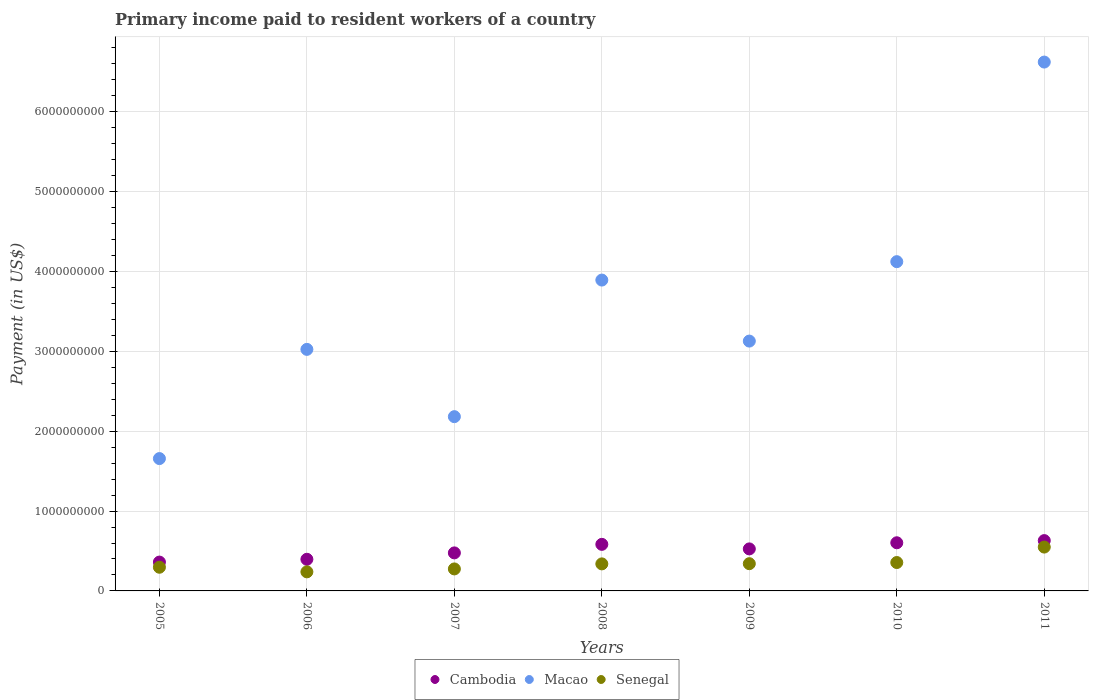How many different coloured dotlines are there?
Provide a short and direct response. 3. Is the number of dotlines equal to the number of legend labels?
Ensure brevity in your answer.  Yes. What is the amount paid to workers in Macao in 2006?
Your response must be concise. 3.02e+09. Across all years, what is the maximum amount paid to workers in Senegal?
Keep it short and to the point. 5.49e+08. Across all years, what is the minimum amount paid to workers in Cambodia?
Your answer should be compact. 3.61e+08. In which year was the amount paid to workers in Macao maximum?
Your answer should be very brief. 2011. What is the total amount paid to workers in Cambodia in the graph?
Provide a short and direct response. 3.58e+09. What is the difference between the amount paid to workers in Macao in 2006 and that in 2007?
Keep it short and to the point. 8.42e+08. What is the difference between the amount paid to workers in Macao in 2006 and the amount paid to workers in Cambodia in 2010?
Keep it short and to the point. 2.42e+09. What is the average amount paid to workers in Cambodia per year?
Offer a very short reply. 5.11e+08. In the year 2008, what is the difference between the amount paid to workers in Macao and amount paid to workers in Cambodia?
Your answer should be very brief. 3.31e+09. What is the ratio of the amount paid to workers in Cambodia in 2006 to that in 2011?
Ensure brevity in your answer.  0.63. Is the difference between the amount paid to workers in Macao in 2006 and 2011 greater than the difference between the amount paid to workers in Cambodia in 2006 and 2011?
Ensure brevity in your answer.  No. What is the difference between the highest and the second highest amount paid to workers in Cambodia?
Provide a succinct answer. 2.71e+07. What is the difference between the highest and the lowest amount paid to workers in Macao?
Offer a terse response. 4.96e+09. In how many years, is the amount paid to workers in Cambodia greater than the average amount paid to workers in Cambodia taken over all years?
Provide a succinct answer. 4. Is the sum of the amount paid to workers in Macao in 2007 and 2009 greater than the maximum amount paid to workers in Cambodia across all years?
Your response must be concise. Yes. Is it the case that in every year, the sum of the amount paid to workers in Cambodia and amount paid to workers in Senegal  is greater than the amount paid to workers in Macao?
Offer a terse response. No. Does the graph contain grids?
Give a very brief answer. Yes. How many legend labels are there?
Your response must be concise. 3. What is the title of the graph?
Provide a short and direct response. Primary income paid to resident workers of a country. What is the label or title of the Y-axis?
Provide a succinct answer. Payment (in US$). What is the Payment (in US$) of Cambodia in 2005?
Give a very brief answer. 3.61e+08. What is the Payment (in US$) of Macao in 2005?
Your answer should be very brief. 1.66e+09. What is the Payment (in US$) in Senegal in 2005?
Make the answer very short. 2.96e+08. What is the Payment (in US$) of Cambodia in 2006?
Ensure brevity in your answer.  3.96e+08. What is the Payment (in US$) in Macao in 2006?
Offer a terse response. 3.02e+09. What is the Payment (in US$) of Senegal in 2006?
Give a very brief answer. 2.39e+08. What is the Payment (in US$) of Cambodia in 2007?
Your answer should be very brief. 4.76e+08. What is the Payment (in US$) in Macao in 2007?
Your response must be concise. 2.18e+09. What is the Payment (in US$) of Senegal in 2007?
Your response must be concise. 2.75e+08. What is the Payment (in US$) in Cambodia in 2008?
Provide a short and direct response. 5.83e+08. What is the Payment (in US$) of Macao in 2008?
Provide a short and direct response. 3.89e+09. What is the Payment (in US$) of Senegal in 2008?
Give a very brief answer. 3.39e+08. What is the Payment (in US$) in Cambodia in 2009?
Offer a very short reply. 5.26e+08. What is the Payment (in US$) in Macao in 2009?
Ensure brevity in your answer.  3.13e+09. What is the Payment (in US$) in Senegal in 2009?
Provide a succinct answer. 3.41e+08. What is the Payment (in US$) of Cambodia in 2010?
Make the answer very short. 6.03e+08. What is the Payment (in US$) in Macao in 2010?
Provide a succinct answer. 4.12e+09. What is the Payment (in US$) of Senegal in 2010?
Provide a short and direct response. 3.56e+08. What is the Payment (in US$) of Cambodia in 2011?
Make the answer very short. 6.30e+08. What is the Payment (in US$) of Macao in 2011?
Provide a succinct answer. 6.62e+09. What is the Payment (in US$) in Senegal in 2011?
Your answer should be compact. 5.49e+08. Across all years, what is the maximum Payment (in US$) of Cambodia?
Give a very brief answer. 6.30e+08. Across all years, what is the maximum Payment (in US$) in Macao?
Keep it short and to the point. 6.62e+09. Across all years, what is the maximum Payment (in US$) in Senegal?
Your response must be concise. 5.49e+08. Across all years, what is the minimum Payment (in US$) in Cambodia?
Keep it short and to the point. 3.61e+08. Across all years, what is the minimum Payment (in US$) in Macao?
Keep it short and to the point. 1.66e+09. Across all years, what is the minimum Payment (in US$) of Senegal?
Ensure brevity in your answer.  2.39e+08. What is the total Payment (in US$) in Cambodia in the graph?
Offer a very short reply. 3.58e+09. What is the total Payment (in US$) in Macao in the graph?
Provide a short and direct response. 2.46e+1. What is the total Payment (in US$) of Senegal in the graph?
Provide a succinct answer. 2.39e+09. What is the difference between the Payment (in US$) in Cambodia in 2005 and that in 2006?
Ensure brevity in your answer.  -3.50e+07. What is the difference between the Payment (in US$) in Macao in 2005 and that in 2006?
Make the answer very short. -1.37e+09. What is the difference between the Payment (in US$) in Senegal in 2005 and that in 2006?
Make the answer very short. 5.77e+07. What is the difference between the Payment (in US$) of Cambodia in 2005 and that in 2007?
Offer a very short reply. -1.15e+08. What is the difference between the Payment (in US$) in Macao in 2005 and that in 2007?
Offer a terse response. -5.25e+08. What is the difference between the Payment (in US$) in Senegal in 2005 and that in 2007?
Keep it short and to the point. 2.11e+07. What is the difference between the Payment (in US$) in Cambodia in 2005 and that in 2008?
Offer a very short reply. -2.22e+08. What is the difference between the Payment (in US$) of Macao in 2005 and that in 2008?
Provide a short and direct response. -2.24e+09. What is the difference between the Payment (in US$) of Senegal in 2005 and that in 2008?
Your answer should be compact. -4.20e+07. What is the difference between the Payment (in US$) in Cambodia in 2005 and that in 2009?
Your answer should be very brief. -1.65e+08. What is the difference between the Payment (in US$) in Macao in 2005 and that in 2009?
Keep it short and to the point. -1.47e+09. What is the difference between the Payment (in US$) of Senegal in 2005 and that in 2009?
Offer a very short reply. -4.46e+07. What is the difference between the Payment (in US$) of Cambodia in 2005 and that in 2010?
Your answer should be compact. -2.42e+08. What is the difference between the Payment (in US$) of Macao in 2005 and that in 2010?
Ensure brevity in your answer.  -2.47e+09. What is the difference between the Payment (in US$) of Senegal in 2005 and that in 2010?
Provide a short and direct response. -5.90e+07. What is the difference between the Payment (in US$) of Cambodia in 2005 and that in 2011?
Offer a terse response. -2.69e+08. What is the difference between the Payment (in US$) of Macao in 2005 and that in 2011?
Offer a terse response. -4.96e+09. What is the difference between the Payment (in US$) of Senegal in 2005 and that in 2011?
Make the answer very short. -2.52e+08. What is the difference between the Payment (in US$) in Cambodia in 2006 and that in 2007?
Ensure brevity in your answer.  -8.00e+07. What is the difference between the Payment (in US$) of Macao in 2006 and that in 2007?
Offer a terse response. 8.42e+08. What is the difference between the Payment (in US$) in Senegal in 2006 and that in 2007?
Your response must be concise. -3.67e+07. What is the difference between the Payment (in US$) in Cambodia in 2006 and that in 2008?
Your answer should be very brief. -1.87e+08. What is the difference between the Payment (in US$) of Macao in 2006 and that in 2008?
Your answer should be very brief. -8.68e+08. What is the difference between the Payment (in US$) in Senegal in 2006 and that in 2008?
Your response must be concise. -9.97e+07. What is the difference between the Payment (in US$) of Cambodia in 2006 and that in 2009?
Your answer should be very brief. -1.30e+08. What is the difference between the Payment (in US$) in Macao in 2006 and that in 2009?
Keep it short and to the point. -1.04e+08. What is the difference between the Payment (in US$) in Senegal in 2006 and that in 2009?
Provide a succinct answer. -1.02e+08. What is the difference between the Payment (in US$) of Cambodia in 2006 and that in 2010?
Your answer should be compact. -2.07e+08. What is the difference between the Payment (in US$) in Macao in 2006 and that in 2010?
Make the answer very short. -1.10e+09. What is the difference between the Payment (in US$) in Senegal in 2006 and that in 2010?
Your answer should be compact. -1.17e+08. What is the difference between the Payment (in US$) in Cambodia in 2006 and that in 2011?
Provide a short and direct response. -2.34e+08. What is the difference between the Payment (in US$) of Macao in 2006 and that in 2011?
Your answer should be compact. -3.60e+09. What is the difference between the Payment (in US$) in Senegal in 2006 and that in 2011?
Ensure brevity in your answer.  -3.10e+08. What is the difference between the Payment (in US$) in Cambodia in 2007 and that in 2008?
Your response must be concise. -1.07e+08. What is the difference between the Payment (in US$) of Macao in 2007 and that in 2008?
Provide a succinct answer. -1.71e+09. What is the difference between the Payment (in US$) in Senegal in 2007 and that in 2008?
Give a very brief answer. -6.31e+07. What is the difference between the Payment (in US$) of Cambodia in 2007 and that in 2009?
Provide a short and direct response. -4.99e+07. What is the difference between the Payment (in US$) in Macao in 2007 and that in 2009?
Provide a short and direct response. -9.46e+08. What is the difference between the Payment (in US$) of Senegal in 2007 and that in 2009?
Offer a very short reply. -6.56e+07. What is the difference between the Payment (in US$) of Cambodia in 2007 and that in 2010?
Give a very brief answer. -1.27e+08. What is the difference between the Payment (in US$) of Macao in 2007 and that in 2010?
Offer a very short reply. -1.94e+09. What is the difference between the Payment (in US$) in Senegal in 2007 and that in 2010?
Offer a very short reply. -8.01e+07. What is the difference between the Payment (in US$) in Cambodia in 2007 and that in 2011?
Make the answer very short. -1.54e+08. What is the difference between the Payment (in US$) in Macao in 2007 and that in 2011?
Your answer should be compact. -4.44e+09. What is the difference between the Payment (in US$) of Senegal in 2007 and that in 2011?
Give a very brief answer. -2.74e+08. What is the difference between the Payment (in US$) of Cambodia in 2008 and that in 2009?
Make the answer very short. 5.69e+07. What is the difference between the Payment (in US$) in Macao in 2008 and that in 2009?
Make the answer very short. 7.64e+08. What is the difference between the Payment (in US$) of Senegal in 2008 and that in 2009?
Your answer should be very brief. -2.51e+06. What is the difference between the Payment (in US$) in Cambodia in 2008 and that in 2010?
Your response must be concise. -1.99e+07. What is the difference between the Payment (in US$) in Macao in 2008 and that in 2010?
Your answer should be very brief. -2.30e+08. What is the difference between the Payment (in US$) of Senegal in 2008 and that in 2010?
Your answer should be very brief. -1.70e+07. What is the difference between the Payment (in US$) in Cambodia in 2008 and that in 2011?
Ensure brevity in your answer.  -4.70e+07. What is the difference between the Payment (in US$) of Macao in 2008 and that in 2011?
Provide a short and direct response. -2.73e+09. What is the difference between the Payment (in US$) of Senegal in 2008 and that in 2011?
Your response must be concise. -2.10e+08. What is the difference between the Payment (in US$) in Cambodia in 2009 and that in 2010?
Ensure brevity in your answer.  -7.68e+07. What is the difference between the Payment (in US$) in Macao in 2009 and that in 2010?
Your answer should be compact. -9.95e+08. What is the difference between the Payment (in US$) in Senegal in 2009 and that in 2010?
Make the answer very short. -1.45e+07. What is the difference between the Payment (in US$) of Cambodia in 2009 and that in 2011?
Your response must be concise. -1.04e+08. What is the difference between the Payment (in US$) of Macao in 2009 and that in 2011?
Give a very brief answer. -3.49e+09. What is the difference between the Payment (in US$) of Senegal in 2009 and that in 2011?
Keep it short and to the point. -2.08e+08. What is the difference between the Payment (in US$) in Cambodia in 2010 and that in 2011?
Your answer should be compact. -2.71e+07. What is the difference between the Payment (in US$) in Macao in 2010 and that in 2011?
Provide a short and direct response. -2.50e+09. What is the difference between the Payment (in US$) of Senegal in 2010 and that in 2011?
Ensure brevity in your answer.  -1.93e+08. What is the difference between the Payment (in US$) in Cambodia in 2005 and the Payment (in US$) in Macao in 2006?
Keep it short and to the point. -2.66e+09. What is the difference between the Payment (in US$) in Cambodia in 2005 and the Payment (in US$) in Senegal in 2006?
Ensure brevity in your answer.  1.22e+08. What is the difference between the Payment (in US$) in Macao in 2005 and the Payment (in US$) in Senegal in 2006?
Your answer should be very brief. 1.42e+09. What is the difference between the Payment (in US$) of Cambodia in 2005 and the Payment (in US$) of Macao in 2007?
Give a very brief answer. -1.82e+09. What is the difference between the Payment (in US$) in Cambodia in 2005 and the Payment (in US$) in Senegal in 2007?
Keep it short and to the point. 8.57e+07. What is the difference between the Payment (in US$) of Macao in 2005 and the Payment (in US$) of Senegal in 2007?
Your answer should be very brief. 1.38e+09. What is the difference between the Payment (in US$) in Cambodia in 2005 and the Payment (in US$) in Macao in 2008?
Make the answer very short. -3.53e+09. What is the difference between the Payment (in US$) in Cambodia in 2005 and the Payment (in US$) in Senegal in 2008?
Offer a terse response. 2.26e+07. What is the difference between the Payment (in US$) of Macao in 2005 and the Payment (in US$) of Senegal in 2008?
Offer a very short reply. 1.32e+09. What is the difference between the Payment (in US$) of Cambodia in 2005 and the Payment (in US$) of Macao in 2009?
Your answer should be very brief. -2.77e+09. What is the difference between the Payment (in US$) of Cambodia in 2005 and the Payment (in US$) of Senegal in 2009?
Provide a succinct answer. 2.01e+07. What is the difference between the Payment (in US$) of Macao in 2005 and the Payment (in US$) of Senegal in 2009?
Ensure brevity in your answer.  1.32e+09. What is the difference between the Payment (in US$) of Cambodia in 2005 and the Payment (in US$) of Macao in 2010?
Offer a terse response. -3.76e+09. What is the difference between the Payment (in US$) in Cambodia in 2005 and the Payment (in US$) in Senegal in 2010?
Make the answer very short. 5.60e+06. What is the difference between the Payment (in US$) in Macao in 2005 and the Payment (in US$) in Senegal in 2010?
Your answer should be compact. 1.30e+09. What is the difference between the Payment (in US$) in Cambodia in 2005 and the Payment (in US$) in Macao in 2011?
Provide a succinct answer. -6.26e+09. What is the difference between the Payment (in US$) of Cambodia in 2005 and the Payment (in US$) of Senegal in 2011?
Provide a short and direct response. -1.88e+08. What is the difference between the Payment (in US$) in Macao in 2005 and the Payment (in US$) in Senegal in 2011?
Offer a terse response. 1.11e+09. What is the difference between the Payment (in US$) of Cambodia in 2006 and the Payment (in US$) of Macao in 2007?
Ensure brevity in your answer.  -1.79e+09. What is the difference between the Payment (in US$) of Cambodia in 2006 and the Payment (in US$) of Senegal in 2007?
Make the answer very short. 1.21e+08. What is the difference between the Payment (in US$) in Macao in 2006 and the Payment (in US$) in Senegal in 2007?
Make the answer very short. 2.75e+09. What is the difference between the Payment (in US$) in Cambodia in 2006 and the Payment (in US$) in Macao in 2008?
Ensure brevity in your answer.  -3.50e+09. What is the difference between the Payment (in US$) of Cambodia in 2006 and the Payment (in US$) of Senegal in 2008?
Give a very brief answer. 5.76e+07. What is the difference between the Payment (in US$) in Macao in 2006 and the Payment (in US$) in Senegal in 2008?
Ensure brevity in your answer.  2.69e+09. What is the difference between the Payment (in US$) in Cambodia in 2006 and the Payment (in US$) in Macao in 2009?
Keep it short and to the point. -2.73e+09. What is the difference between the Payment (in US$) in Cambodia in 2006 and the Payment (in US$) in Senegal in 2009?
Your response must be concise. 5.51e+07. What is the difference between the Payment (in US$) of Macao in 2006 and the Payment (in US$) of Senegal in 2009?
Provide a succinct answer. 2.68e+09. What is the difference between the Payment (in US$) in Cambodia in 2006 and the Payment (in US$) in Macao in 2010?
Provide a succinct answer. -3.73e+09. What is the difference between the Payment (in US$) of Cambodia in 2006 and the Payment (in US$) of Senegal in 2010?
Provide a succinct answer. 4.06e+07. What is the difference between the Payment (in US$) in Macao in 2006 and the Payment (in US$) in Senegal in 2010?
Ensure brevity in your answer.  2.67e+09. What is the difference between the Payment (in US$) of Cambodia in 2006 and the Payment (in US$) of Macao in 2011?
Provide a short and direct response. -6.23e+09. What is the difference between the Payment (in US$) in Cambodia in 2006 and the Payment (in US$) in Senegal in 2011?
Your answer should be compact. -1.53e+08. What is the difference between the Payment (in US$) of Macao in 2006 and the Payment (in US$) of Senegal in 2011?
Offer a very short reply. 2.48e+09. What is the difference between the Payment (in US$) in Cambodia in 2007 and the Payment (in US$) in Macao in 2008?
Make the answer very short. -3.42e+09. What is the difference between the Payment (in US$) in Cambodia in 2007 and the Payment (in US$) in Senegal in 2008?
Your answer should be very brief. 1.38e+08. What is the difference between the Payment (in US$) of Macao in 2007 and the Payment (in US$) of Senegal in 2008?
Give a very brief answer. 1.84e+09. What is the difference between the Payment (in US$) of Cambodia in 2007 and the Payment (in US$) of Macao in 2009?
Your answer should be compact. -2.65e+09. What is the difference between the Payment (in US$) of Cambodia in 2007 and the Payment (in US$) of Senegal in 2009?
Your answer should be very brief. 1.35e+08. What is the difference between the Payment (in US$) in Macao in 2007 and the Payment (in US$) in Senegal in 2009?
Provide a succinct answer. 1.84e+09. What is the difference between the Payment (in US$) of Cambodia in 2007 and the Payment (in US$) of Macao in 2010?
Ensure brevity in your answer.  -3.65e+09. What is the difference between the Payment (in US$) of Cambodia in 2007 and the Payment (in US$) of Senegal in 2010?
Offer a very short reply. 1.21e+08. What is the difference between the Payment (in US$) in Macao in 2007 and the Payment (in US$) in Senegal in 2010?
Offer a very short reply. 1.83e+09. What is the difference between the Payment (in US$) in Cambodia in 2007 and the Payment (in US$) in Macao in 2011?
Keep it short and to the point. -6.15e+09. What is the difference between the Payment (in US$) of Cambodia in 2007 and the Payment (in US$) of Senegal in 2011?
Provide a short and direct response. -7.28e+07. What is the difference between the Payment (in US$) in Macao in 2007 and the Payment (in US$) in Senegal in 2011?
Keep it short and to the point. 1.63e+09. What is the difference between the Payment (in US$) of Cambodia in 2008 and the Payment (in US$) of Macao in 2009?
Give a very brief answer. -2.55e+09. What is the difference between the Payment (in US$) of Cambodia in 2008 and the Payment (in US$) of Senegal in 2009?
Provide a succinct answer. 2.42e+08. What is the difference between the Payment (in US$) of Macao in 2008 and the Payment (in US$) of Senegal in 2009?
Provide a succinct answer. 3.55e+09. What is the difference between the Payment (in US$) in Cambodia in 2008 and the Payment (in US$) in Macao in 2010?
Ensure brevity in your answer.  -3.54e+09. What is the difference between the Payment (in US$) of Cambodia in 2008 and the Payment (in US$) of Senegal in 2010?
Provide a short and direct response. 2.28e+08. What is the difference between the Payment (in US$) of Macao in 2008 and the Payment (in US$) of Senegal in 2010?
Your answer should be compact. 3.54e+09. What is the difference between the Payment (in US$) of Cambodia in 2008 and the Payment (in US$) of Macao in 2011?
Keep it short and to the point. -6.04e+09. What is the difference between the Payment (in US$) in Cambodia in 2008 and the Payment (in US$) in Senegal in 2011?
Give a very brief answer. 3.41e+07. What is the difference between the Payment (in US$) of Macao in 2008 and the Payment (in US$) of Senegal in 2011?
Make the answer very short. 3.34e+09. What is the difference between the Payment (in US$) of Cambodia in 2009 and the Payment (in US$) of Macao in 2010?
Make the answer very short. -3.60e+09. What is the difference between the Payment (in US$) of Cambodia in 2009 and the Payment (in US$) of Senegal in 2010?
Your answer should be very brief. 1.71e+08. What is the difference between the Payment (in US$) in Macao in 2009 and the Payment (in US$) in Senegal in 2010?
Offer a very short reply. 2.77e+09. What is the difference between the Payment (in US$) of Cambodia in 2009 and the Payment (in US$) of Macao in 2011?
Make the answer very short. -6.10e+09. What is the difference between the Payment (in US$) in Cambodia in 2009 and the Payment (in US$) in Senegal in 2011?
Provide a succinct answer. -2.28e+07. What is the difference between the Payment (in US$) of Macao in 2009 and the Payment (in US$) of Senegal in 2011?
Make the answer very short. 2.58e+09. What is the difference between the Payment (in US$) of Cambodia in 2010 and the Payment (in US$) of Macao in 2011?
Provide a short and direct response. -6.02e+09. What is the difference between the Payment (in US$) in Cambodia in 2010 and the Payment (in US$) in Senegal in 2011?
Provide a succinct answer. 5.40e+07. What is the difference between the Payment (in US$) of Macao in 2010 and the Payment (in US$) of Senegal in 2011?
Offer a very short reply. 3.57e+09. What is the average Payment (in US$) in Cambodia per year?
Offer a terse response. 5.11e+08. What is the average Payment (in US$) of Macao per year?
Give a very brief answer. 3.52e+09. What is the average Payment (in US$) in Senegal per year?
Give a very brief answer. 3.42e+08. In the year 2005, what is the difference between the Payment (in US$) in Cambodia and Payment (in US$) in Macao?
Provide a succinct answer. -1.30e+09. In the year 2005, what is the difference between the Payment (in US$) of Cambodia and Payment (in US$) of Senegal?
Offer a very short reply. 6.46e+07. In the year 2005, what is the difference between the Payment (in US$) of Macao and Payment (in US$) of Senegal?
Keep it short and to the point. 1.36e+09. In the year 2006, what is the difference between the Payment (in US$) in Cambodia and Payment (in US$) in Macao?
Offer a terse response. -2.63e+09. In the year 2006, what is the difference between the Payment (in US$) of Cambodia and Payment (in US$) of Senegal?
Offer a very short reply. 1.57e+08. In the year 2006, what is the difference between the Payment (in US$) in Macao and Payment (in US$) in Senegal?
Keep it short and to the point. 2.79e+09. In the year 2007, what is the difference between the Payment (in US$) of Cambodia and Payment (in US$) of Macao?
Ensure brevity in your answer.  -1.71e+09. In the year 2007, what is the difference between the Payment (in US$) of Cambodia and Payment (in US$) of Senegal?
Offer a terse response. 2.01e+08. In the year 2007, what is the difference between the Payment (in US$) in Macao and Payment (in US$) in Senegal?
Make the answer very short. 1.91e+09. In the year 2008, what is the difference between the Payment (in US$) in Cambodia and Payment (in US$) in Macao?
Your response must be concise. -3.31e+09. In the year 2008, what is the difference between the Payment (in US$) in Cambodia and Payment (in US$) in Senegal?
Provide a short and direct response. 2.45e+08. In the year 2008, what is the difference between the Payment (in US$) of Macao and Payment (in US$) of Senegal?
Keep it short and to the point. 3.55e+09. In the year 2009, what is the difference between the Payment (in US$) in Cambodia and Payment (in US$) in Macao?
Your answer should be compact. -2.60e+09. In the year 2009, what is the difference between the Payment (in US$) of Cambodia and Payment (in US$) of Senegal?
Ensure brevity in your answer.  1.85e+08. In the year 2009, what is the difference between the Payment (in US$) of Macao and Payment (in US$) of Senegal?
Provide a succinct answer. 2.79e+09. In the year 2010, what is the difference between the Payment (in US$) in Cambodia and Payment (in US$) in Macao?
Ensure brevity in your answer.  -3.52e+09. In the year 2010, what is the difference between the Payment (in US$) of Cambodia and Payment (in US$) of Senegal?
Ensure brevity in your answer.  2.47e+08. In the year 2010, what is the difference between the Payment (in US$) of Macao and Payment (in US$) of Senegal?
Offer a very short reply. 3.77e+09. In the year 2011, what is the difference between the Payment (in US$) in Cambodia and Payment (in US$) in Macao?
Ensure brevity in your answer.  -5.99e+09. In the year 2011, what is the difference between the Payment (in US$) of Cambodia and Payment (in US$) of Senegal?
Your answer should be compact. 8.11e+07. In the year 2011, what is the difference between the Payment (in US$) in Macao and Payment (in US$) in Senegal?
Ensure brevity in your answer.  6.07e+09. What is the ratio of the Payment (in US$) of Cambodia in 2005 to that in 2006?
Your answer should be very brief. 0.91. What is the ratio of the Payment (in US$) in Macao in 2005 to that in 2006?
Ensure brevity in your answer.  0.55. What is the ratio of the Payment (in US$) in Senegal in 2005 to that in 2006?
Your response must be concise. 1.24. What is the ratio of the Payment (in US$) of Cambodia in 2005 to that in 2007?
Keep it short and to the point. 0.76. What is the ratio of the Payment (in US$) of Macao in 2005 to that in 2007?
Provide a succinct answer. 0.76. What is the ratio of the Payment (in US$) of Senegal in 2005 to that in 2007?
Keep it short and to the point. 1.08. What is the ratio of the Payment (in US$) in Cambodia in 2005 to that in 2008?
Your response must be concise. 0.62. What is the ratio of the Payment (in US$) in Macao in 2005 to that in 2008?
Provide a short and direct response. 0.43. What is the ratio of the Payment (in US$) in Senegal in 2005 to that in 2008?
Your response must be concise. 0.88. What is the ratio of the Payment (in US$) of Cambodia in 2005 to that in 2009?
Provide a short and direct response. 0.69. What is the ratio of the Payment (in US$) of Macao in 2005 to that in 2009?
Keep it short and to the point. 0.53. What is the ratio of the Payment (in US$) in Senegal in 2005 to that in 2009?
Offer a terse response. 0.87. What is the ratio of the Payment (in US$) in Cambodia in 2005 to that in 2010?
Provide a short and direct response. 0.6. What is the ratio of the Payment (in US$) of Macao in 2005 to that in 2010?
Your answer should be compact. 0.4. What is the ratio of the Payment (in US$) of Senegal in 2005 to that in 2010?
Give a very brief answer. 0.83. What is the ratio of the Payment (in US$) in Cambodia in 2005 to that in 2011?
Provide a short and direct response. 0.57. What is the ratio of the Payment (in US$) of Macao in 2005 to that in 2011?
Offer a very short reply. 0.25. What is the ratio of the Payment (in US$) of Senegal in 2005 to that in 2011?
Your response must be concise. 0.54. What is the ratio of the Payment (in US$) of Cambodia in 2006 to that in 2007?
Offer a terse response. 0.83. What is the ratio of the Payment (in US$) of Macao in 2006 to that in 2007?
Your answer should be very brief. 1.39. What is the ratio of the Payment (in US$) in Senegal in 2006 to that in 2007?
Ensure brevity in your answer.  0.87. What is the ratio of the Payment (in US$) in Cambodia in 2006 to that in 2008?
Your answer should be compact. 0.68. What is the ratio of the Payment (in US$) of Macao in 2006 to that in 2008?
Your response must be concise. 0.78. What is the ratio of the Payment (in US$) of Senegal in 2006 to that in 2008?
Make the answer very short. 0.71. What is the ratio of the Payment (in US$) of Cambodia in 2006 to that in 2009?
Offer a very short reply. 0.75. What is the ratio of the Payment (in US$) of Macao in 2006 to that in 2009?
Your answer should be very brief. 0.97. What is the ratio of the Payment (in US$) in Senegal in 2006 to that in 2009?
Keep it short and to the point. 0.7. What is the ratio of the Payment (in US$) in Cambodia in 2006 to that in 2010?
Provide a short and direct response. 0.66. What is the ratio of the Payment (in US$) in Macao in 2006 to that in 2010?
Provide a short and direct response. 0.73. What is the ratio of the Payment (in US$) of Senegal in 2006 to that in 2010?
Offer a very short reply. 0.67. What is the ratio of the Payment (in US$) in Cambodia in 2006 to that in 2011?
Keep it short and to the point. 0.63. What is the ratio of the Payment (in US$) in Macao in 2006 to that in 2011?
Your answer should be very brief. 0.46. What is the ratio of the Payment (in US$) of Senegal in 2006 to that in 2011?
Offer a very short reply. 0.43. What is the ratio of the Payment (in US$) of Cambodia in 2007 to that in 2008?
Give a very brief answer. 0.82. What is the ratio of the Payment (in US$) of Macao in 2007 to that in 2008?
Keep it short and to the point. 0.56. What is the ratio of the Payment (in US$) of Senegal in 2007 to that in 2008?
Offer a very short reply. 0.81. What is the ratio of the Payment (in US$) of Cambodia in 2007 to that in 2009?
Provide a short and direct response. 0.91. What is the ratio of the Payment (in US$) of Macao in 2007 to that in 2009?
Your answer should be compact. 0.7. What is the ratio of the Payment (in US$) of Senegal in 2007 to that in 2009?
Your answer should be compact. 0.81. What is the ratio of the Payment (in US$) of Cambodia in 2007 to that in 2010?
Your response must be concise. 0.79. What is the ratio of the Payment (in US$) of Macao in 2007 to that in 2010?
Ensure brevity in your answer.  0.53. What is the ratio of the Payment (in US$) of Senegal in 2007 to that in 2010?
Your response must be concise. 0.77. What is the ratio of the Payment (in US$) in Cambodia in 2007 to that in 2011?
Keep it short and to the point. 0.76. What is the ratio of the Payment (in US$) in Macao in 2007 to that in 2011?
Ensure brevity in your answer.  0.33. What is the ratio of the Payment (in US$) in Senegal in 2007 to that in 2011?
Give a very brief answer. 0.5. What is the ratio of the Payment (in US$) of Cambodia in 2008 to that in 2009?
Make the answer very short. 1.11. What is the ratio of the Payment (in US$) of Macao in 2008 to that in 2009?
Your response must be concise. 1.24. What is the ratio of the Payment (in US$) in Macao in 2008 to that in 2010?
Give a very brief answer. 0.94. What is the ratio of the Payment (in US$) of Senegal in 2008 to that in 2010?
Provide a succinct answer. 0.95. What is the ratio of the Payment (in US$) in Cambodia in 2008 to that in 2011?
Provide a short and direct response. 0.93. What is the ratio of the Payment (in US$) of Macao in 2008 to that in 2011?
Ensure brevity in your answer.  0.59. What is the ratio of the Payment (in US$) in Senegal in 2008 to that in 2011?
Give a very brief answer. 0.62. What is the ratio of the Payment (in US$) of Cambodia in 2009 to that in 2010?
Offer a very short reply. 0.87. What is the ratio of the Payment (in US$) of Macao in 2009 to that in 2010?
Keep it short and to the point. 0.76. What is the ratio of the Payment (in US$) of Senegal in 2009 to that in 2010?
Your answer should be very brief. 0.96. What is the ratio of the Payment (in US$) in Cambodia in 2009 to that in 2011?
Offer a terse response. 0.84. What is the ratio of the Payment (in US$) of Macao in 2009 to that in 2011?
Offer a terse response. 0.47. What is the ratio of the Payment (in US$) of Senegal in 2009 to that in 2011?
Ensure brevity in your answer.  0.62. What is the ratio of the Payment (in US$) in Cambodia in 2010 to that in 2011?
Your answer should be very brief. 0.96. What is the ratio of the Payment (in US$) of Macao in 2010 to that in 2011?
Your response must be concise. 0.62. What is the ratio of the Payment (in US$) in Senegal in 2010 to that in 2011?
Your response must be concise. 0.65. What is the difference between the highest and the second highest Payment (in US$) in Cambodia?
Make the answer very short. 2.71e+07. What is the difference between the highest and the second highest Payment (in US$) in Macao?
Keep it short and to the point. 2.50e+09. What is the difference between the highest and the second highest Payment (in US$) in Senegal?
Offer a very short reply. 1.93e+08. What is the difference between the highest and the lowest Payment (in US$) in Cambodia?
Offer a very short reply. 2.69e+08. What is the difference between the highest and the lowest Payment (in US$) in Macao?
Your answer should be compact. 4.96e+09. What is the difference between the highest and the lowest Payment (in US$) in Senegal?
Offer a very short reply. 3.10e+08. 